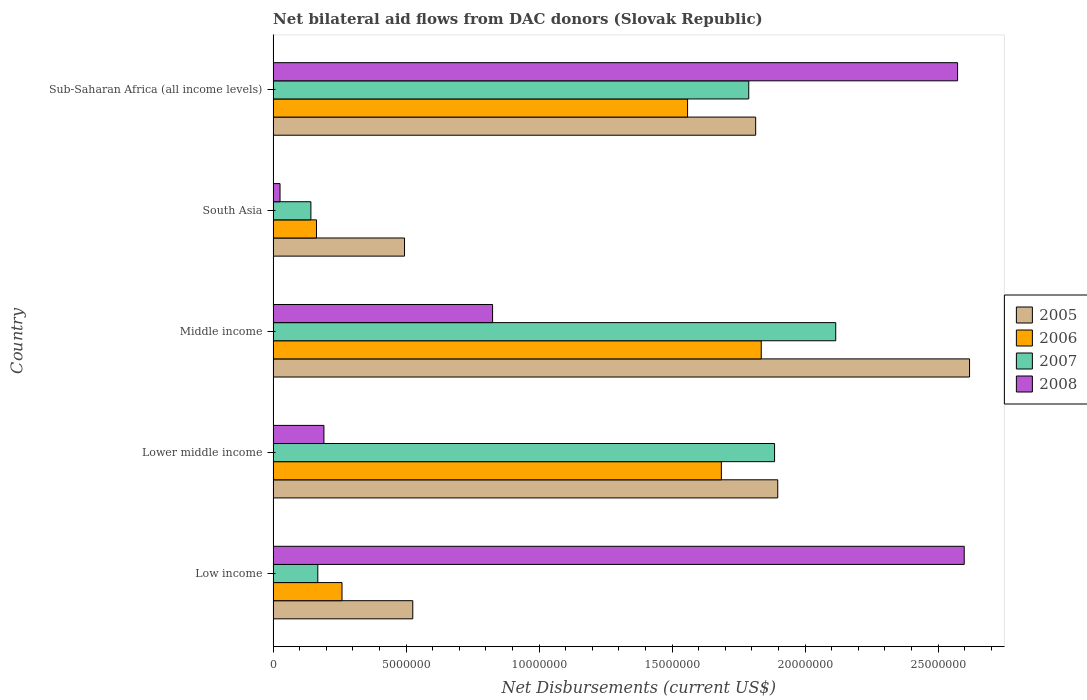How many different coloured bars are there?
Make the answer very short. 4. Are the number of bars per tick equal to the number of legend labels?
Your answer should be compact. Yes. Are the number of bars on each tick of the Y-axis equal?
Your answer should be very brief. Yes. How many bars are there on the 4th tick from the bottom?
Offer a very short reply. 4. What is the label of the 5th group of bars from the top?
Keep it short and to the point. Low income. What is the net bilateral aid flows in 2008 in South Asia?
Provide a short and direct response. 2.60e+05. Across all countries, what is the maximum net bilateral aid flows in 2005?
Your answer should be very brief. 2.62e+07. Across all countries, what is the minimum net bilateral aid flows in 2005?
Provide a short and direct response. 4.94e+06. In which country was the net bilateral aid flows in 2006 minimum?
Give a very brief answer. South Asia. What is the total net bilateral aid flows in 2007 in the graph?
Offer a terse response. 6.10e+07. What is the difference between the net bilateral aid flows in 2006 in Middle income and that in South Asia?
Offer a very short reply. 1.67e+07. What is the difference between the net bilateral aid flows in 2005 in South Asia and the net bilateral aid flows in 2008 in Sub-Saharan Africa (all income levels)?
Give a very brief answer. -2.08e+07. What is the average net bilateral aid flows in 2005 per country?
Give a very brief answer. 1.47e+07. What is the difference between the net bilateral aid flows in 2006 and net bilateral aid flows in 2007 in Low income?
Offer a very short reply. 9.10e+05. What is the ratio of the net bilateral aid flows in 2007 in Low income to that in Sub-Saharan Africa (all income levels)?
Give a very brief answer. 0.09. Is the net bilateral aid flows in 2005 in Low income less than that in Lower middle income?
Provide a short and direct response. Yes. Is the difference between the net bilateral aid flows in 2006 in Low income and Lower middle income greater than the difference between the net bilateral aid flows in 2007 in Low income and Lower middle income?
Make the answer very short. Yes. What is the difference between the highest and the second highest net bilateral aid flows in 2005?
Your answer should be very brief. 7.21e+06. What is the difference between the highest and the lowest net bilateral aid flows in 2005?
Your answer should be very brief. 2.12e+07. In how many countries, is the net bilateral aid flows in 2007 greater than the average net bilateral aid flows in 2007 taken over all countries?
Offer a very short reply. 3. Is it the case that in every country, the sum of the net bilateral aid flows in 2006 and net bilateral aid flows in 2008 is greater than the sum of net bilateral aid flows in 2007 and net bilateral aid flows in 2005?
Keep it short and to the point. No. What does the 2nd bar from the top in Low income represents?
Provide a succinct answer. 2007. What does the 4th bar from the bottom in Lower middle income represents?
Provide a short and direct response. 2008. Is it the case that in every country, the sum of the net bilateral aid flows in 2005 and net bilateral aid flows in 2007 is greater than the net bilateral aid flows in 2008?
Keep it short and to the point. No. Are all the bars in the graph horizontal?
Give a very brief answer. Yes. How many countries are there in the graph?
Your answer should be very brief. 5. What is the difference between two consecutive major ticks on the X-axis?
Your response must be concise. 5.00e+06. Does the graph contain any zero values?
Provide a short and direct response. No. How many legend labels are there?
Provide a short and direct response. 4. What is the title of the graph?
Provide a succinct answer. Net bilateral aid flows from DAC donors (Slovak Republic). What is the label or title of the X-axis?
Ensure brevity in your answer.  Net Disbursements (current US$). What is the Net Disbursements (current US$) of 2005 in Low income?
Ensure brevity in your answer.  5.25e+06. What is the Net Disbursements (current US$) in 2006 in Low income?
Offer a terse response. 2.59e+06. What is the Net Disbursements (current US$) in 2007 in Low income?
Give a very brief answer. 1.68e+06. What is the Net Disbursements (current US$) in 2008 in Low income?
Make the answer very short. 2.60e+07. What is the Net Disbursements (current US$) in 2005 in Lower middle income?
Provide a short and direct response. 1.90e+07. What is the Net Disbursements (current US$) of 2006 in Lower middle income?
Give a very brief answer. 1.68e+07. What is the Net Disbursements (current US$) in 2007 in Lower middle income?
Provide a succinct answer. 1.88e+07. What is the Net Disbursements (current US$) of 2008 in Lower middle income?
Make the answer very short. 1.91e+06. What is the Net Disbursements (current US$) in 2005 in Middle income?
Keep it short and to the point. 2.62e+07. What is the Net Disbursements (current US$) in 2006 in Middle income?
Ensure brevity in your answer.  1.84e+07. What is the Net Disbursements (current US$) of 2007 in Middle income?
Provide a succinct answer. 2.12e+07. What is the Net Disbursements (current US$) in 2008 in Middle income?
Provide a succinct answer. 8.25e+06. What is the Net Disbursements (current US$) in 2005 in South Asia?
Ensure brevity in your answer.  4.94e+06. What is the Net Disbursements (current US$) in 2006 in South Asia?
Give a very brief answer. 1.63e+06. What is the Net Disbursements (current US$) in 2007 in South Asia?
Offer a very short reply. 1.42e+06. What is the Net Disbursements (current US$) in 2008 in South Asia?
Provide a short and direct response. 2.60e+05. What is the Net Disbursements (current US$) of 2005 in Sub-Saharan Africa (all income levels)?
Your answer should be very brief. 1.81e+07. What is the Net Disbursements (current US$) of 2006 in Sub-Saharan Africa (all income levels)?
Ensure brevity in your answer.  1.56e+07. What is the Net Disbursements (current US$) in 2007 in Sub-Saharan Africa (all income levels)?
Provide a short and direct response. 1.79e+07. What is the Net Disbursements (current US$) of 2008 in Sub-Saharan Africa (all income levels)?
Provide a succinct answer. 2.57e+07. Across all countries, what is the maximum Net Disbursements (current US$) in 2005?
Offer a terse response. 2.62e+07. Across all countries, what is the maximum Net Disbursements (current US$) of 2006?
Your response must be concise. 1.84e+07. Across all countries, what is the maximum Net Disbursements (current US$) in 2007?
Your answer should be very brief. 2.12e+07. Across all countries, what is the maximum Net Disbursements (current US$) of 2008?
Your response must be concise. 2.60e+07. Across all countries, what is the minimum Net Disbursements (current US$) in 2005?
Your answer should be compact. 4.94e+06. Across all countries, what is the minimum Net Disbursements (current US$) of 2006?
Provide a succinct answer. 1.63e+06. Across all countries, what is the minimum Net Disbursements (current US$) of 2007?
Offer a terse response. 1.42e+06. Across all countries, what is the minimum Net Disbursements (current US$) of 2008?
Offer a terse response. 2.60e+05. What is the total Net Disbursements (current US$) in 2005 in the graph?
Ensure brevity in your answer.  7.35e+07. What is the total Net Disbursements (current US$) of 2006 in the graph?
Your answer should be very brief. 5.50e+07. What is the total Net Disbursements (current US$) of 2007 in the graph?
Make the answer very short. 6.10e+07. What is the total Net Disbursements (current US$) in 2008 in the graph?
Keep it short and to the point. 6.21e+07. What is the difference between the Net Disbursements (current US$) in 2005 in Low income and that in Lower middle income?
Ensure brevity in your answer.  -1.37e+07. What is the difference between the Net Disbursements (current US$) in 2006 in Low income and that in Lower middle income?
Provide a succinct answer. -1.43e+07. What is the difference between the Net Disbursements (current US$) in 2007 in Low income and that in Lower middle income?
Make the answer very short. -1.72e+07. What is the difference between the Net Disbursements (current US$) in 2008 in Low income and that in Lower middle income?
Provide a short and direct response. 2.41e+07. What is the difference between the Net Disbursements (current US$) in 2005 in Low income and that in Middle income?
Ensure brevity in your answer.  -2.09e+07. What is the difference between the Net Disbursements (current US$) of 2006 in Low income and that in Middle income?
Make the answer very short. -1.58e+07. What is the difference between the Net Disbursements (current US$) in 2007 in Low income and that in Middle income?
Provide a succinct answer. -1.95e+07. What is the difference between the Net Disbursements (current US$) of 2008 in Low income and that in Middle income?
Provide a succinct answer. 1.77e+07. What is the difference between the Net Disbursements (current US$) of 2006 in Low income and that in South Asia?
Keep it short and to the point. 9.60e+05. What is the difference between the Net Disbursements (current US$) in 2008 in Low income and that in South Asia?
Provide a short and direct response. 2.57e+07. What is the difference between the Net Disbursements (current US$) of 2005 in Low income and that in Sub-Saharan Africa (all income levels)?
Offer a very short reply. -1.29e+07. What is the difference between the Net Disbursements (current US$) in 2006 in Low income and that in Sub-Saharan Africa (all income levels)?
Provide a succinct answer. -1.30e+07. What is the difference between the Net Disbursements (current US$) in 2007 in Low income and that in Sub-Saharan Africa (all income levels)?
Provide a short and direct response. -1.62e+07. What is the difference between the Net Disbursements (current US$) of 2005 in Lower middle income and that in Middle income?
Your response must be concise. -7.21e+06. What is the difference between the Net Disbursements (current US$) of 2006 in Lower middle income and that in Middle income?
Give a very brief answer. -1.50e+06. What is the difference between the Net Disbursements (current US$) in 2007 in Lower middle income and that in Middle income?
Your answer should be compact. -2.30e+06. What is the difference between the Net Disbursements (current US$) in 2008 in Lower middle income and that in Middle income?
Your response must be concise. -6.34e+06. What is the difference between the Net Disbursements (current US$) in 2005 in Lower middle income and that in South Asia?
Provide a succinct answer. 1.40e+07. What is the difference between the Net Disbursements (current US$) of 2006 in Lower middle income and that in South Asia?
Your response must be concise. 1.52e+07. What is the difference between the Net Disbursements (current US$) in 2007 in Lower middle income and that in South Asia?
Your response must be concise. 1.74e+07. What is the difference between the Net Disbursements (current US$) in 2008 in Lower middle income and that in South Asia?
Provide a succinct answer. 1.65e+06. What is the difference between the Net Disbursements (current US$) of 2005 in Lower middle income and that in Sub-Saharan Africa (all income levels)?
Ensure brevity in your answer.  8.30e+05. What is the difference between the Net Disbursements (current US$) of 2006 in Lower middle income and that in Sub-Saharan Africa (all income levels)?
Your answer should be very brief. 1.27e+06. What is the difference between the Net Disbursements (current US$) of 2007 in Lower middle income and that in Sub-Saharan Africa (all income levels)?
Give a very brief answer. 9.70e+05. What is the difference between the Net Disbursements (current US$) in 2008 in Lower middle income and that in Sub-Saharan Africa (all income levels)?
Give a very brief answer. -2.38e+07. What is the difference between the Net Disbursements (current US$) of 2005 in Middle income and that in South Asia?
Provide a succinct answer. 2.12e+07. What is the difference between the Net Disbursements (current US$) of 2006 in Middle income and that in South Asia?
Make the answer very short. 1.67e+07. What is the difference between the Net Disbursements (current US$) in 2007 in Middle income and that in South Asia?
Your response must be concise. 1.97e+07. What is the difference between the Net Disbursements (current US$) in 2008 in Middle income and that in South Asia?
Provide a succinct answer. 7.99e+06. What is the difference between the Net Disbursements (current US$) of 2005 in Middle income and that in Sub-Saharan Africa (all income levels)?
Make the answer very short. 8.04e+06. What is the difference between the Net Disbursements (current US$) in 2006 in Middle income and that in Sub-Saharan Africa (all income levels)?
Give a very brief answer. 2.77e+06. What is the difference between the Net Disbursements (current US$) of 2007 in Middle income and that in Sub-Saharan Africa (all income levels)?
Make the answer very short. 3.27e+06. What is the difference between the Net Disbursements (current US$) of 2008 in Middle income and that in Sub-Saharan Africa (all income levels)?
Ensure brevity in your answer.  -1.75e+07. What is the difference between the Net Disbursements (current US$) of 2005 in South Asia and that in Sub-Saharan Africa (all income levels)?
Your answer should be compact. -1.32e+07. What is the difference between the Net Disbursements (current US$) of 2006 in South Asia and that in Sub-Saharan Africa (all income levels)?
Make the answer very short. -1.40e+07. What is the difference between the Net Disbursements (current US$) in 2007 in South Asia and that in Sub-Saharan Africa (all income levels)?
Offer a very short reply. -1.65e+07. What is the difference between the Net Disbursements (current US$) of 2008 in South Asia and that in Sub-Saharan Africa (all income levels)?
Keep it short and to the point. -2.55e+07. What is the difference between the Net Disbursements (current US$) of 2005 in Low income and the Net Disbursements (current US$) of 2006 in Lower middle income?
Offer a terse response. -1.16e+07. What is the difference between the Net Disbursements (current US$) in 2005 in Low income and the Net Disbursements (current US$) in 2007 in Lower middle income?
Provide a succinct answer. -1.36e+07. What is the difference between the Net Disbursements (current US$) in 2005 in Low income and the Net Disbursements (current US$) in 2008 in Lower middle income?
Ensure brevity in your answer.  3.34e+06. What is the difference between the Net Disbursements (current US$) in 2006 in Low income and the Net Disbursements (current US$) in 2007 in Lower middle income?
Keep it short and to the point. -1.63e+07. What is the difference between the Net Disbursements (current US$) in 2006 in Low income and the Net Disbursements (current US$) in 2008 in Lower middle income?
Keep it short and to the point. 6.80e+05. What is the difference between the Net Disbursements (current US$) of 2007 in Low income and the Net Disbursements (current US$) of 2008 in Lower middle income?
Provide a succinct answer. -2.30e+05. What is the difference between the Net Disbursements (current US$) in 2005 in Low income and the Net Disbursements (current US$) in 2006 in Middle income?
Provide a short and direct response. -1.31e+07. What is the difference between the Net Disbursements (current US$) in 2005 in Low income and the Net Disbursements (current US$) in 2007 in Middle income?
Offer a very short reply. -1.59e+07. What is the difference between the Net Disbursements (current US$) in 2006 in Low income and the Net Disbursements (current US$) in 2007 in Middle income?
Ensure brevity in your answer.  -1.86e+07. What is the difference between the Net Disbursements (current US$) in 2006 in Low income and the Net Disbursements (current US$) in 2008 in Middle income?
Provide a succinct answer. -5.66e+06. What is the difference between the Net Disbursements (current US$) of 2007 in Low income and the Net Disbursements (current US$) of 2008 in Middle income?
Your answer should be compact. -6.57e+06. What is the difference between the Net Disbursements (current US$) in 2005 in Low income and the Net Disbursements (current US$) in 2006 in South Asia?
Offer a very short reply. 3.62e+06. What is the difference between the Net Disbursements (current US$) in 2005 in Low income and the Net Disbursements (current US$) in 2007 in South Asia?
Give a very brief answer. 3.83e+06. What is the difference between the Net Disbursements (current US$) in 2005 in Low income and the Net Disbursements (current US$) in 2008 in South Asia?
Your response must be concise. 4.99e+06. What is the difference between the Net Disbursements (current US$) in 2006 in Low income and the Net Disbursements (current US$) in 2007 in South Asia?
Your response must be concise. 1.17e+06. What is the difference between the Net Disbursements (current US$) of 2006 in Low income and the Net Disbursements (current US$) of 2008 in South Asia?
Offer a very short reply. 2.33e+06. What is the difference between the Net Disbursements (current US$) of 2007 in Low income and the Net Disbursements (current US$) of 2008 in South Asia?
Your answer should be very brief. 1.42e+06. What is the difference between the Net Disbursements (current US$) in 2005 in Low income and the Net Disbursements (current US$) in 2006 in Sub-Saharan Africa (all income levels)?
Offer a terse response. -1.03e+07. What is the difference between the Net Disbursements (current US$) in 2005 in Low income and the Net Disbursements (current US$) in 2007 in Sub-Saharan Africa (all income levels)?
Provide a succinct answer. -1.26e+07. What is the difference between the Net Disbursements (current US$) in 2005 in Low income and the Net Disbursements (current US$) in 2008 in Sub-Saharan Africa (all income levels)?
Provide a succinct answer. -2.05e+07. What is the difference between the Net Disbursements (current US$) in 2006 in Low income and the Net Disbursements (current US$) in 2007 in Sub-Saharan Africa (all income levels)?
Give a very brief answer. -1.53e+07. What is the difference between the Net Disbursements (current US$) of 2006 in Low income and the Net Disbursements (current US$) of 2008 in Sub-Saharan Africa (all income levels)?
Offer a very short reply. -2.31e+07. What is the difference between the Net Disbursements (current US$) in 2007 in Low income and the Net Disbursements (current US$) in 2008 in Sub-Saharan Africa (all income levels)?
Offer a terse response. -2.40e+07. What is the difference between the Net Disbursements (current US$) of 2005 in Lower middle income and the Net Disbursements (current US$) of 2006 in Middle income?
Provide a succinct answer. 6.20e+05. What is the difference between the Net Disbursements (current US$) of 2005 in Lower middle income and the Net Disbursements (current US$) of 2007 in Middle income?
Offer a very short reply. -2.18e+06. What is the difference between the Net Disbursements (current US$) of 2005 in Lower middle income and the Net Disbursements (current US$) of 2008 in Middle income?
Ensure brevity in your answer.  1.07e+07. What is the difference between the Net Disbursements (current US$) of 2006 in Lower middle income and the Net Disbursements (current US$) of 2007 in Middle income?
Provide a short and direct response. -4.30e+06. What is the difference between the Net Disbursements (current US$) of 2006 in Lower middle income and the Net Disbursements (current US$) of 2008 in Middle income?
Give a very brief answer. 8.60e+06. What is the difference between the Net Disbursements (current US$) of 2007 in Lower middle income and the Net Disbursements (current US$) of 2008 in Middle income?
Your answer should be compact. 1.06e+07. What is the difference between the Net Disbursements (current US$) of 2005 in Lower middle income and the Net Disbursements (current US$) of 2006 in South Asia?
Provide a short and direct response. 1.73e+07. What is the difference between the Net Disbursements (current US$) of 2005 in Lower middle income and the Net Disbursements (current US$) of 2007 in South Asia?
Offer a very short reply. 1.76e+07. What is the difference between the Net Disbursements (current US$) of 2005 in Lower middle income and the Net Disbursements (current US$) of 2008 in South Asia?
Make the answer very short. 1.87e+07. What is the difference between the Net Disbursements (current US$) in 2006 in Lower middle income and the Net Disbursements (current US$) in 2007 in South Asia?
Offer a very short reply. 1.54e+07. What is the difference between the Net Disbursements (current US$) in 2006 in Lower middle income and the Net Disbursements (current US$) in 2008 in South Asia?
Keep it short and to the point. 1.66e+07. What is the difference between the Net Disbursements (current US$) in 2007 in Lower middle income and the Net Disbursements (current US$) in 2008 in South Asia?
Make the answer very short. 1.86e+07. What is the difference between the Net Disbursements (current US$) in 2005 in Lower middle income and the Net Disbursements (current US$) in 2006 in Sub-Saharan Africa (all income levels)?
Make the answer very short. 3.39e+06. What is the difference between the Net Disbursements (current US$) of 2005 in Lower middle income and the Net Disbursements (current US$) of 2007 in Sub-Saharan Africa (all income levels)?
Ensure brevity in your answer.  1.09e+06. What is the difference between the Net Disbursements (current US$) in 2005 in Lower middle income and the Net Disbursements (current US$) in 2008 in Sub-Saharan Africa (all income levels)?
Provide a succinct answer. -6.76e+06. What is the difference between the Net Disbursements (current US$) in 2006 in Lower middle income and the Net Disbursements (current US$) in 2007 in Sub-Saharan Africa (all income levels)?
Keep it short and to the point. -1.03e+06. What is the difference between the Net Disbursements (current US$) of 2006 in Lower middle income and the Net Disbursements (current US$) of 2008 in Sub-Saharan Africa (all income levels)?
Provide a succinct answer. -8.88e+06. What is the difference between the Net Disbursements (current US$) in 2007 in Lower middle income and the Net Disbursements (current US$) in 2008 in Sub-Saharan Africa (all income levels)?
Make the answer very short. -6.88e+06. What is the difference between the Net Disbursements (current US$) of 2005 in Middle income and the Net Disbursements (current US$) of 2006 in South Asia?
Provide a succinct answer. 2.46e+07. What is the difference between the Net Disbursements (current US$) in 2005 in Middle income and the Net Disbursements (current US$) in 2007 in South Asia?
Keep it short and to the point. 2.48e+07. What is the difference between the Net Disbursements (current US$) in 2005 in Middle income and the Net Disbursements (current US$) in 2008 in South Asia?
Provide a short and direct response. 2.59e+07. What is the difference between the Net Disbursements (current US$) of 2006 in Middle income and the Net Disbursements (current US$) of 2007 in South Asia?
Make the answer very short. 1.69e+07. What is the difference between the Net Disbursements (current US$) in 2006 in Middle income and the Net Disbursements (current US$) in 2008 in South Asia?
Offer a terse response. 1.81e+07. What is the difference between the Net Disbursements (current US$) of 2007 in Middle income and the Net Disbursements (current US$) of 2008 in South Asia?
Offer a terse response. 2.09e+07. What is the difference between the Net Disbursements (current US$) of 2005 in Middle income and the Net Disbursements (current US$) of 2006 in Sub-Saharan Africa (all income levels)?
Give a very brief answer. 1.06e+07. What is the difference between the Net Disbursements (current US$) of 2005 in Middle income and the Net Disbursements (current US$) of 2007 in Sub-Saharan Africa (all income levels)?
Provide a succinct answer. 8.30e+06. What is the difference between the Net Disbursements (current US$) of 2005 in Middle income and the Net Disbursements (current US$) of 2008 in Sub-Saharan Africa (all income levels)?
Your answer should be compact. 4.50e+05. What is the difference between the Net Disbursements (current US$) of 2006 in Middle income and the Net Disbursements (current US$) of 2008 in Sub-Saharan Africa (all income levels)?
Provide a succinct answer. -7.38e+06. What is the difference between the Net Disbursements (current US$) in 2007 in Middle income and the Net Disbursements (current US$) in 2008 in Sub-Saharan Africa (all income levels)?
Ensure brevity in your answer.  -4.58e+06. What is the difference between the Net Disbursements (current US$) in 2005 in South Asia and the Net Disbursements (current US$) in 2006 in Sub-Saharan Africa (all income levels)?
Your answer should be compact. -1.06e+07. What is the difference between the Net Disbursements (current US$) of 2005 in South Asia and the Net Disbursements (current US$) of 2007 in Sub-Saharan Africa (all income levels)?
Your answer should be compact. -1.29e+07. What is the difference between the Net Disbursements (current US$) in 2005 in South Asia and the Net Disbursements (current US$) in 2008 in Sub-Saharan Africa (all income levels)?
Your answer should be very brief. -2.08e+07. What is the difference between the Net Disbursements (current US$) of 2006 in South Asia and the Net Disbursements (current US$) of 2007 in Sub-Saharan Africa (all income levels)?
Your response must be concise. -1.62e+07. What is the difference between the Net Disbursements (current US$) of 2006 in South Asia and the Net Disbursements (current US$) of 2008 in Sub-Saharan Africa (all income levels)?
Keep it short and to the point. -2.41e+07. What is the difference between the Net Disbursements (current US$) in 2007 in South Asia and the Net Disbursements (current US$) in 2008 in Sub-Saharan Africa (all income levels)?
Your response must be concise. -2.43e+07. What is the average Net Disbursements (current US$) of 2005 per country?
Your answer should be very brief. 1.47e+07. What is the average Net Disbursements (current US$) of 2006 per country?
Keep it short and to the point. 1.10e+07. What is the average Net Disbursements (current US$) in 2007 per country?
Offer a very short reply. 1.22e+07. What is the average Net Disbursements (current US$) of 2008 per country?
Ensure brevity in your answer.  1.24e+07. What is the difference between the Net Disbursements (current US$) of 2005 and Net Disbursements (current US$) of 2006 in Low income?
Make the answer very short. 2.66e+06. What is the difference between the Net Disbursements (current US$) in 2005 and Net Disbursements (current US$) in 2007 in Low income?
Keep it short and to the point. 3.57e+06. What is the difference between the Net Disbursements (current US$) in 2005 and Net Disbursements (current US$) in 2008 in Low income?
Provide a short and direct response. -2.07e+07. What is the difference between the Net Disbursements (current US$) of 2006 and Net Disbursements (current US$) of 2007 in Low income?
Give a very brief answer. 9.10e+05. What is the difference between the Net Disbursements (current US$) in 2006 and Net Disbursements (current US$) in 2008 in Low income?
Give a very brief answer. -2.34e+07. What is the difference between the Net Disbursements (current US$) of 2007 and Net Disbursements (current US$) of 2008 in Low income?
Ensure brevity in your answer.  -2.43e+07. What is the difference between the Net Disbursements (current US$) of 2005 and Net Disbursements (current US$) of 2006 in Lower middle income?
Your answer should be very brief. 2.12e+06. What is the difference between the Net Disbursements (current US$) in 2005 and Net Disbursements (current US$) in 2007 in Lower middle income?
Provide a succinct answer. 1.20e+05. What is the difference between the Net Disbursements (current US$) in 2005 and Net Disbursements (current US$) in 2008 in Lower middle income?
Your answer should be very brief. 1.71e+07. What is the difference between the Net Disbursements (current US$) of 2006 and Net Disbursements (current US$) of 2008 in Lower middle income?
Give a very brief answer. 1.49e+07. What is the difference between the Net Disbursements (current US$) in 2007 and Net Disbursements (current US$) in 2008 in Lower middle income?
Keep it short and to the point. 1.69e+07. What is the difference between the Net Disbursements (current US$) of 2005 and Net Disbursements (current US$) of 2006 in Middle income?
Your answer should be compact. 7.83e+06. What is the difference between the Net Disbursements (current US$) in 2005 and Net Disbursements (current US$) in 2007 in Middle income?
Make the answer very short. 5.03e+06. What is the difference between the Net Disbursements (current US$) of 2005 and Net Disbursements (current US$) of 2008 in Middle income?
Keep it short and to the point. 1.79e+07. What is the difference between the Net Disbursements (current US$) of 2006 and Net Disbursements (current US$) of 2007 in Middle income?
Provide a succinct answer. -2.80e+06. What is the difference between the Net Disbursements (current US$) of 2006 and Net Disbursements (current US$) of 2008 in Middle income?
Provide a succinct answer. 1.01e+07. What is the difference between the Net Disbursements (current US$) in 2007 and Net Disbursements (current US$) in 2008 in Middle income?
Your response must be concise. 1.29e+07. What is the difference between the Net Disbursements (current US$) of 2005 and Net Disbursements (current US$) of 2006 in South Asia?
Ensure brevity in your answer.  3.31e+06. What is the difference between the Net Disbursements (current US$) of 2005 and Net Disbursements (current US$) of 2007 in South Asia?
Ensure brevity in your answer.  3.52e+06. What is the difference between the Net Disbursements (current US$) in 2005 and Net Disbursements (current US$) in 2008 in South Asia?
Your answer should be very brief. 4.68e+06. What is the difference between the Net Disbursements (current US$) in 2006 and Net Disbursements (current US$) in 2008 in South Asia?
Offer a very short reply. 1.37e+06. What is the difference between the Net Disbursements (current US$) of 2007 and Net Disbursements (current US$) of 2008 in South Asia?
Your answer should be very brief. 1.16e+06. What is the difference between the Net Disbursements (current US$) in 2005 and Net Disbursements (current US$) in 2006 in Sub-Saharan Africa (all income levels)?
Provide a succinct answer. 2.56e+06. What is the difference between the Net Disbursements (current US$) of 2005 and Net Disbursements (current US$) of 2008 in Sub-Saharan Africa (all income levels)?
Your answer should be compact. -7.59e+06. What is the difference between the Net Disbursements (current US$) of 2006 and Net Disbursements (current US$) of 2007 in Sub-Saharan Africa (all income levels)?
Your answer should be compact. -2.30e+06. What is the difference between the Net Disbursements (current US$) of 2006 and Net Disbursements (current US$) of 2008 in Sub-Saharan Africa (all income levels)?
Provide a short and direct response. -1.02e+07. What is the difference between the Net Disbursements (current US$) in 2007 and Net Disbursements (current US$) in 2008 in Sub-Saharan Africa (all income levels)?
Ensure brevity in your answer.  -7.85e+06. What is the ratio of the Net Disbursements (current US$) in 2005 in Low income to that in Lower middle income?
Offer a terse response. 0.28. What is the ratio of the Net Disbursements (current US$) of 2006 in Low income to that in Lower middle income?
Provide a short and direct response. 0.15. What is the ratio of the Net Disbursements (current US$) of 2007 in Low income to that in Lower middle income?
Your response must be concise. 0.09. What is the ratio of the Net Disbursements (current US$) in 2008 in Low income to that in Lower middle income?
Your response must be concise. 13.6. What is the ratio of the Net Disbursements (current US$) in 2005 in Low income to that in Middle income?
Provide a succinct answer. 0.2. What is the ratio of the Net Disbursements (current US$) in 2006 in Low income to that in Middle income?
Your answer should be very brief. 0.14. What is the ratio of the Net Disbursements (current US$) in 2007 in Low income to that in Middle income?
Your answer should be compact. 0.08. What is the ratio of the Net Disbursements (current US$) of 2008 in Low income to that in Middle income?
Make the answer very short. 3.15. What is the ratio of the Net Disbursements (current US$) of 2005 in Low income to that in South Asia?
Keep it short and to the point. 1.06. What is the ratio of the Net Disbursements (current US$) of 2006 in Low income to that in South Asia?
Give a very brief answer. 1.59. What is the ratio of the Net Disbursements (current US$) in 2007 in Low income to that in South Asia?
Provide a succinct answer. 1.18. What is the ratio of the Net Disbursements (current US$) in 2008 in Low income to that in South Asia?
Offer a very short reply. 99.92. What is the ratio of the Net Disbursements (current US$) of 2005 in Low income to that in Sub-Saharan Africa (all income levels)?
Your answer should be very brief. 0.29. What is the ratio of the Net Disbursements (current US$) of 2006 in Low income to that in Sub-Saharan Africa (all income levels)?
Offer a terse response. 0.17. What is the ratio of the Net Disbursements (current US$) of 2007 in Low income to that in Sub-Saharan Africa (all income levels)?
Ensure brevity in your answer.  0.09. What is the ratio of the Net Disbursements (current US$) in 2008 in Low income to that in Sub-Saharan Africa (all income levels)?
Offer a terse response. 1.01. What is the ratio of the Net Disbursements (current US$) in 2005 in Lower middle income to that in Middle income?
Your answer should be compact. 0.72. What is the ratio of the Net Disbursements (current US$) in 2006 in Lower middle income to that in Middle income?
Offer a very short reply. 0.92. What is the ratio of the Net Disbursements (current US$) in 2007 in Lower middle income to that in Middle income?
Give a very brief answer. 0.89. What is the ratio of the Net Disbursements (current US$) of 2008 in Lower middle income to that in Middle income?
Offer a very short reply. 0.23. What is the ratio of the Net Disbursements (current US$) in 2005 in Lower middle income to that in South Asia?
Provide a short and direct response. 3.84. What is the ratio of the Net Disbursements (current US$) of 2006 in Lower middle income to that in South Asia?
Keep it short and to the point. 10.34. What is the ratio of the Net Disbursements (current US$) in 2007 in Lower middle income to that in South Asia?
Give a very brief answer. 13.27. What is the ratio of the Net Disbursements (current US$) in 2008 in Lower middle income to that in South Asia?
Offer a very short reply. 7.35. What is the ratio of the Net Disbursements (current US$) in 2005 in Lower middle income to that in Sub-Saharan Africa (all income levels)?
Offer a very short reply. 1.05. What is the ratio of the Net Disbursements (current US$) of 2006 in Lower middle income to that in Sub-Saharan Africa (all income levels)?
Ensure brevity in your answer.  1.08. What is the ratio of the Net Disbursements (current US$) of 2007 in Lower middle income to that in Sub-Saharan Africa (all income levels)?
Offer a very short reply. 1.05. What is the ratio of the Net Disbursements (current US$) of 2008 in Lower middle income to that in Sub-Saharan Africa (all income levels)?
Provide a succinct answer. 0.07. What is the ratio of the Net Disbursements (current US$) in 2005 in Middle income to that in South Asia?
Keep it short and to the point. 5.3. What is the ratio of the Net Disbursements (current US$) of 2006 in Middle income to that in South Asia?
Offer a terse response. 11.26. What is the ratio of the Net Disbursements (current US$) in 2007 in Middle income to that in South Asia?
Offer a very short reply. 14.89. What is the ratio of the Net Disbursements (current US$) in 2008 in Middle income to that in South Asia?
Offer a very short reply. 31.73. What is the ratio of the Net Disbursements (current US$) of 2005 in Middle income to that in Sub-Saharan Africa (all income levels)?
Your answer should be compact. 1.44. What is the ratio of the Net Disbursements (current US$) in 2006 in Middle income to that in Sub-Saharan Africa (all income levels)?
Offer a terse response. 1.18. What is the ratio of the Net Disbursements (current US$) in 2007 in Middle income to that in Sub-Saharan Africa (all income levels)?
Your answer should be compact. 1.18. What is the ratio of the Net Disbursements (current US$) in 2008 in Middle income to that in Sub-Saharan Africa (all income levels)?
Your answer should be compact. 0.32. What is the ratio of the Net Disbursements (current US$) in 2005 in South Asia to that in Sub-Saharan Africa (all income levels)?
Offer a terse response. 0.27. What is the ratio of the Net Disbursements (current US$) of 2006 in South Asia to that in Sub-Saharan Africa (all income levels)?
Make the answer very short. 0.1. What is the ratio of the Net Disbursements (current US$) of 2007 in South Asia to that in Sub-Saharan Africa (all income levels)?
Your answer should be very brief. 0.08. What is the ratio of the Net Disbursements (current US$) in 2008 in South Asia to that in Sub-Saharan Africa (all income levels)?
Your answer should be compact. 0.01. What is the difference between the highest and the second highest Net Disbursements (current US$) in 2005?
Provide a short and direct response. 7.21e+06. What is the difference between the highest and the second highest Net Disbursements (current US$) of 2006?
Offer a very short reply. 1.50e+06. What is the difference between the highest and the second highest Net Disbursements (current US$) in 2007?
Provide a succinct answer. 2.30e+06. What is the difference between the highest and the lowest Net Disbursements (current US$) of 2005?
Your response must be concise. 2.12e+07. What is the difference between the highest and the lowest Net Disbursements (current US$) in 2006?
Give a very brief answer. 1.67e+07. What is the difference between the highest and the lowest Net Disbursements (current US$) in 2007?
Your answer should be compact. 1.97e+07. What is the difference between the highest and the lowest Net Disbursements (current US$) in 2008?
Offer a terse response. 2.57e+07. 